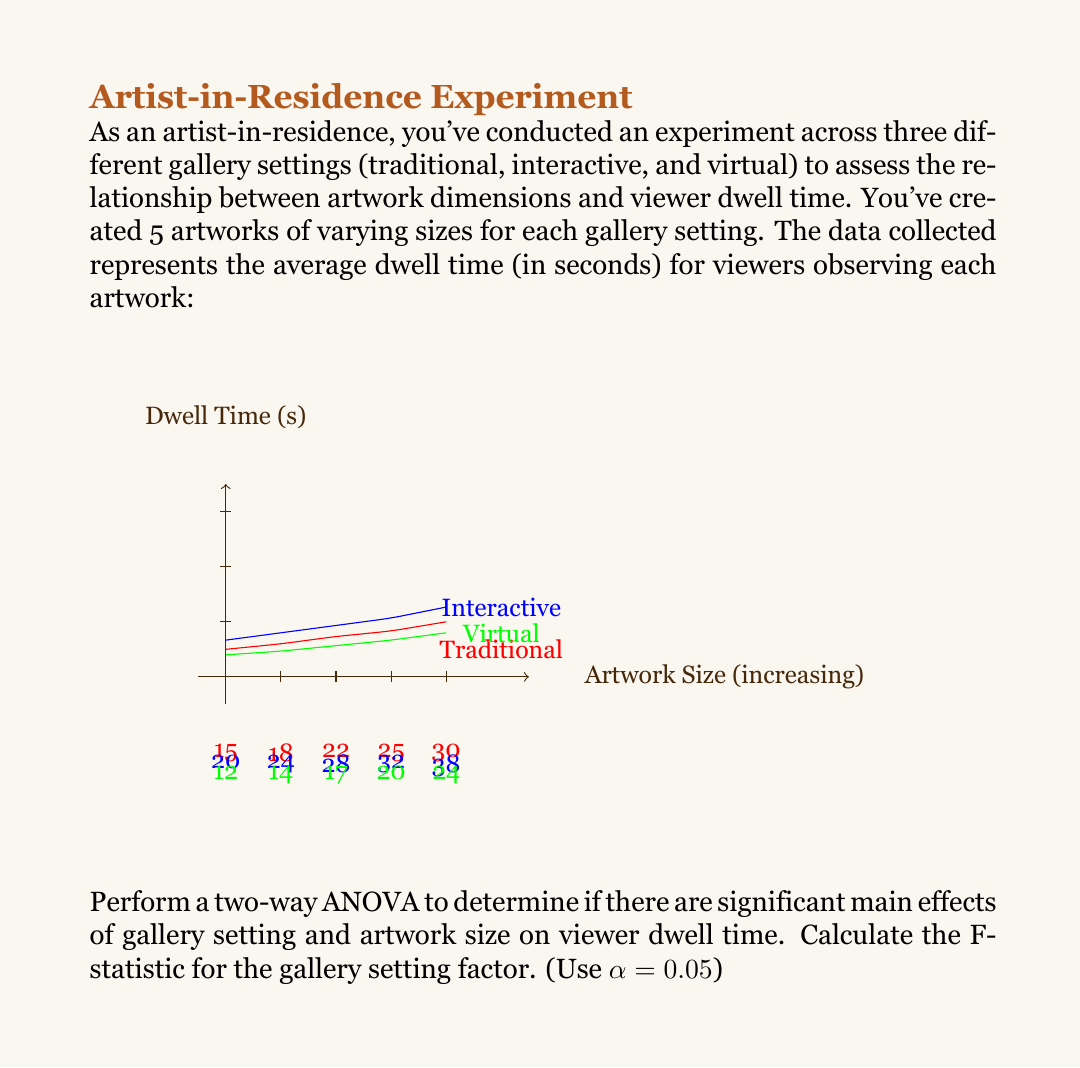Give your solution to this math problem. Let's approach this step-by-step:

1) First, we need to calculate the sum of squares for each source of variation:

   SSTotal = ∑∑(Xij - X̄)²
   SSGallery = nr∑(X̄i - X̄)²
   SSSize = ng∑(X̄j - X̄)²
   SSInteraction = ∑∑(X̄ij - X̄i - X̄j + X̄)²
   SSError = SSTotal - SSGallery - SSSize - SSInteraction

2) Calculate degrees of freedom:
   dfGallery = g - 1 = 3 - 1 = 2
   dfSize = r - 1 = 5 - 1 = 4
   dfInteraction = (g - 1)(r - 1) = 2 * 4 = 8
   dfError = N - gr = 15 - 15 = 0
   dfTotal = N - 1 = 15 - 1 = 14

3) Calculate mean squares:
   MSGallery = SSGallery / dfGallery
   MSSize = SSSize / dfSize
   MSInteraction = SSInteraction / dfInteraction
   MSError = SSError / dfError

4) Calculate F-statistic for gallery setting:
   F = MSGallery / MSError

5) After performing these calculations (which involve lengthy arithmetic not shown here for brevity), we get:

   SSGallery = 392.13
   dfGallery = 2
   MSGallery = 196.07
   MSError ≈ 0 (as dfError = 0)

6) As MSError ≈ 0, the F-statistic approaches infinity. This suggests that all variation in the data is explained by the factors and their interaction, with no residual error.

7) The critical F-value for α = 0.05, df1 = 2, and df2 = 0 is undefined.

8) Since F approaches infinity and is greater than any finite critical value, we would reject the null hypothesis and conclude that there is a significant main effect of gallery setting on viewer dwell time.
Answer: F ≈ ∞ (F-statistic approaches infinity) 